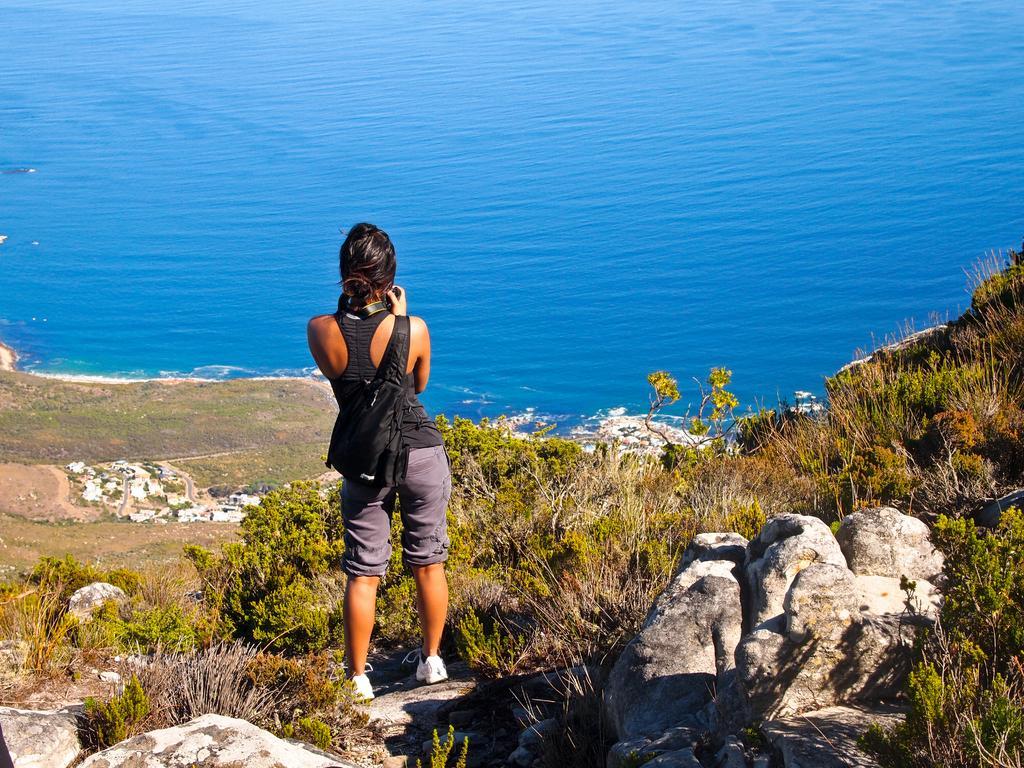How would you summarize this image in a sentence or two? Here in this picture we can see a woman standing over a place and we can see she is carrying a bag with her and we can see rock stones present on the ground over there and we can also see grass and plants present all over there and in the front we can see water present all over there and we can see she is holding something in her hand over there. 